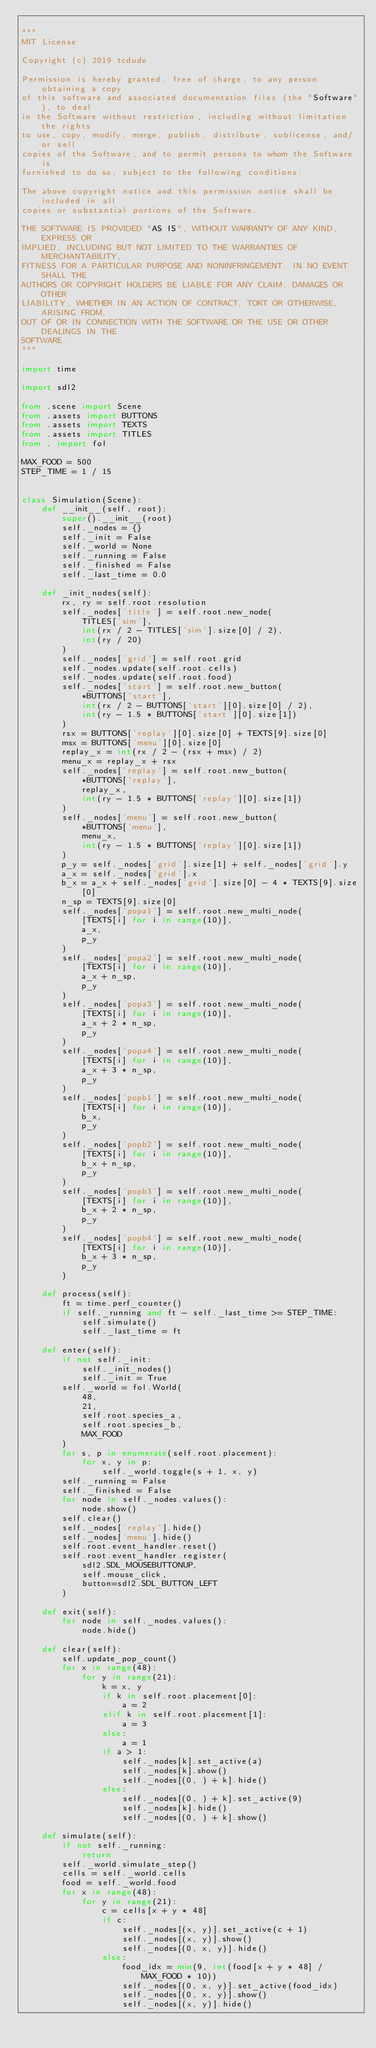Convert code to text. <code><loc_0><loc_0><loc_500><loc_500><_Python_>
"""
MIT License

Copyright (c) 2019 tcdude

Permission is hereby granted, free of charge, to any person obtaining a copy
of this software and associated documentation files (the "Software"), to deal
in the Software without restriction, including without limitation the rights
to use, copy, modify, merge, publish, distribute, sublicense, and/or sell
copies of the Software, and to permit persons to whom the Software is
furnished to do so, subject to the following conditions:

The above copyright notice and this permission notice shall be included in all
copies or substantial portions of the Software.

THE SOFTWARE IS PROVIDED "AS IS", WITHOUT WARRANTY OF ANY KIND, EXPRESS OR
IMPLIED, INCLUDING BUT NOT LIMITED TO THE WARRANTIES OF MERCHANTABILITY,
FITNESS FOR A PARTICULAR PURPOSE AND NONINFRINGEMENT. IN NO EVENT SHALL THE
AUTHORS OR COPYRIGHT HOLDERS BE LIABLE FOR ANY CLAIM, DAMAGES OR OTHER
LIABILITY, WHETHER IN AN ACTION OF CONTRACT, TORT OR OTHERWISE, ARISING FROM,
OUT OF OR IN CONNECTION WITH THE SOFTWARE OR THE USE OR OTHER DEALINGS IN THE
SOFTWARE.
"""

import time

import sdl2

from .scene import Scene
from .assets import BUTTONS
from .assets import TEXTS
from .assets import TITLES
from . import fol

MAX_FOOD = 500
STEP_TIME = 1 / 15


class Simulation(Scene):
    def __init__(self, root):
        super().__init__(root)
        self._nodes = {}
        self._init = False
        self._world = None
        self._running = False
        self._finished = False
        self._last_time = 0.0

    def _init_nodes(self):
        rx, ry = self.root.resolution
        self._nodes['title'] = self.root.new_node(
            TITLES['sim'],
            int(rx / 2 - TITLES['sim'].size[0] / 2),
            int(ry / 20)
        )
        self._nodes['grid'] = self.root.grid
        self._nodes.update(self.root.cells)
        self._nodes.update(self.root.food)
        self._nodes['start'] = self.root.new_button(
            *BUTTONS['start'],
            int(rx / 2 - BUTTONS['start'][0].size[0] / 2),
            int(ry - 1.5 * BUTTONS['start'][0].size[1])
        )
        rsx = BUTTONS['replay'][0].size[0] + TEXTS[9].size[0]
        msx = BUTTONS['menu'][0].size[0]
        replay_x = int(rx / 2 - (rsx + msx) / 2)
        menu_x = replay_x + rsx
        self._nodes['replay'] = self.root.new_button(
            *BUTTONS['replay'],
            replay_x,
            int(ry - 1.5 * BUTTONS['replay'][0].size[1])
        )
        self._nodes['menu'] = self.root.new_button(
            *BUTTONS['menu'],
            menu_x,
            int(ry - 1.5 * BUTTONS['replay'][0].size[1])
        )
        p_y = self._nodes['grid'].size[1] + self._nodes['grid'].y
        a_x = self._nodes['grid'].x
        b_x = a_x + self._nodes['grid'].size[0] - 4 * TEXTS[9].size[0]
        n_sp = TEXTS[9].size[0]
        self._nodes['popa1'] = self.root.new_multi_node(
            [TEXTS[i] for i in range(10)],
            a_x,
            p_y
        )
        self._nodes['popa2'] = self.root.new_multi_node(
            [TEXTS[i] for i in range(10)],
            a_x + n_sp,
            p_y
        )
        self._nodes['popa3'] = self.root.new_multi_node(
            [TEXTS[i] for i in range(10)],
            a_x + 2 * n_sp,
            p_y
        )
        self._nodes['popa4'] = self.root.new_multi_node(
            [TEXTS[i] for i in range(10)],
            a_x + 3 * n_sp,
            p_y
        )
        self._nodes['popb1'] = self.root.new_multi_node(
            [TEXTS[i] for i in range(10)],
            b_x,
            p_y
        )
        self._nodes['popb2'] = self.root.new_multi_node(
            [TEXTS[i] for i in range(10)],
            b_x + n_sp,
            p_y
        )
        self._nodes['popb3'] = self.root.new_multi_node(
            [TEXTS[i] for i in range(10)],
            b_x + 2 * n_sp,
            p_y
        )
        self._nodes['popb4'] = self.root.new_multi_node(
            [TEXTS[i] for i in range(10)],
            b_x + 3 * n_sp,
            p_y
        )

    def process(self):
        ft = time.perf_counter()
        if self._running and ft - self._last_time >= STEP_TIME:
            self.simulate()
            self._last_time = ft

    def enter(self):
        if not self._init:
            self._init_nodes()
            self._init = True
        self._world = fol.World(
            48, 
            21, 
            self.root.species_a, 
            self.root.species_b, 
            MAX_FOOD
        )
        for s, p in enumerate(self.root.placement):
            for x, y in p:
                self._world.toggle(s + 1, x, y)
        self._running = False
        self._finished = False
        for node in self._nodes.values():
            node.show()
        self.clear()
        self._nodes['replay'].hide()
        self._nodes['menu'].hide()
        self.root.event_handler.reset()
        self.root.event_handler.register(
            sdl2.SDL_MOUSEBUTTONUP,
            self.mouse_click,
            button=sdl2.SDL_BUTTON_LEFT
        )

    def exit(self):
        for node in self._nodes.values():
            node.hide()

    def clear(self):
        self.update_pop_count()
        for x in range(48):
            for y in range(21):
                k = x, y
                if k in self.root.placement[0]:
                    a = 2
                elif k in self.root.placement[1]:
                    a = 3
                else:
                    a = 1
                if a > 1:
                    self._nodes[k].set_active(a)
                    self._nodes[k].show()
                    self._nodes[(0, ) + k].hide()
                else:
                    self._nodes[(0, ) + k].set_active(9)
                    self._nodes[k].hide()
                    self._nodes[(0, ) + k].show()

    def simulate(self):
        if not self._running:
            return
        self._world.simulate_step()
        cells = self._world.cells
        food = self._world.food
        for x in range(48):
            for y in range(21):
                c = cells[x + y * 48]
                if c:
                    self._nodes[(x, y)].set_active(c + 1)
                    self._nodes[(x, y)].show()
                    self._nodes[(0, x, y)].hide()
                else:    
                    food_idx = min(9, int(food[x + y * 48] / MAX_FOOD * 10))
                    self._nodes[(0, x, y)].set_active(food_idx)
                    self._nodes[(0, x, y)].show()
                    self._nodes[(x, y)].hide()</code> 